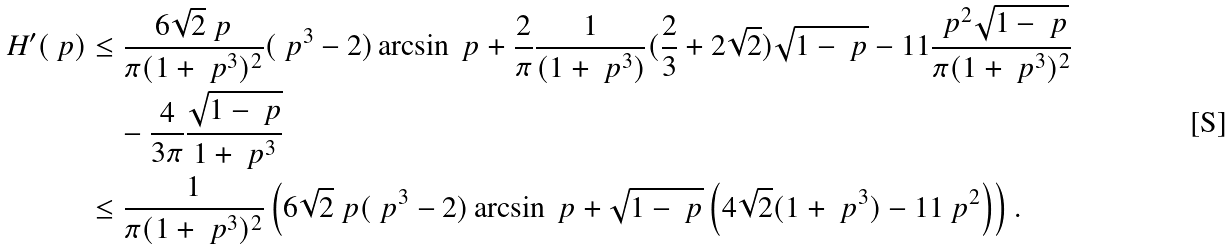<formula> <loc_0><loc_0><loc_500><loc_500>H ^ { \prime } ( \ p ) & \leq \frac { 6 \sqrt { 2 } \ p } { \pi ( 1 + \ p ^ { 3 } ) ^ { 2 } } ( \ p ^ { 3 } - 2 ) \arcsin { \ p } + \frac { 2 } { \pi } \frac { 1 } { ( 1 + \ p ^ { 3 } ) } ( \frac { 2 } { 3 } + 2 \sqrt { 2 } ) \sqrt { 1 - \ p } - 1 1 \frac { \ p ^ { 2 } \sqrt { 1 - \ p } } { \pi ( 1 + \ p ^ { 3 } ) ^ { 2 } } \\ & \quad - \frac { 4 } { 3 \pi } \frac { \sqrt { 1 - \ p } } { 1 + \ p ^ { 3 } } \\ & \leq \frac { 1 } { \pi ( 1 + \ p ^ { 3 } ) ^ { 2 } } \left ( 6 \sqrt { 2 } \ p ( \ p ^ { 3 } - 2 ) \arcsin { \ p } + \sqrt { 1 - \ p } \left ( 4 \sqrt { 2 } ( 1 + \ p ^ { 3 } ) - 1 1 \ p ^ { 2 } \right ) \right ) .</formula> 